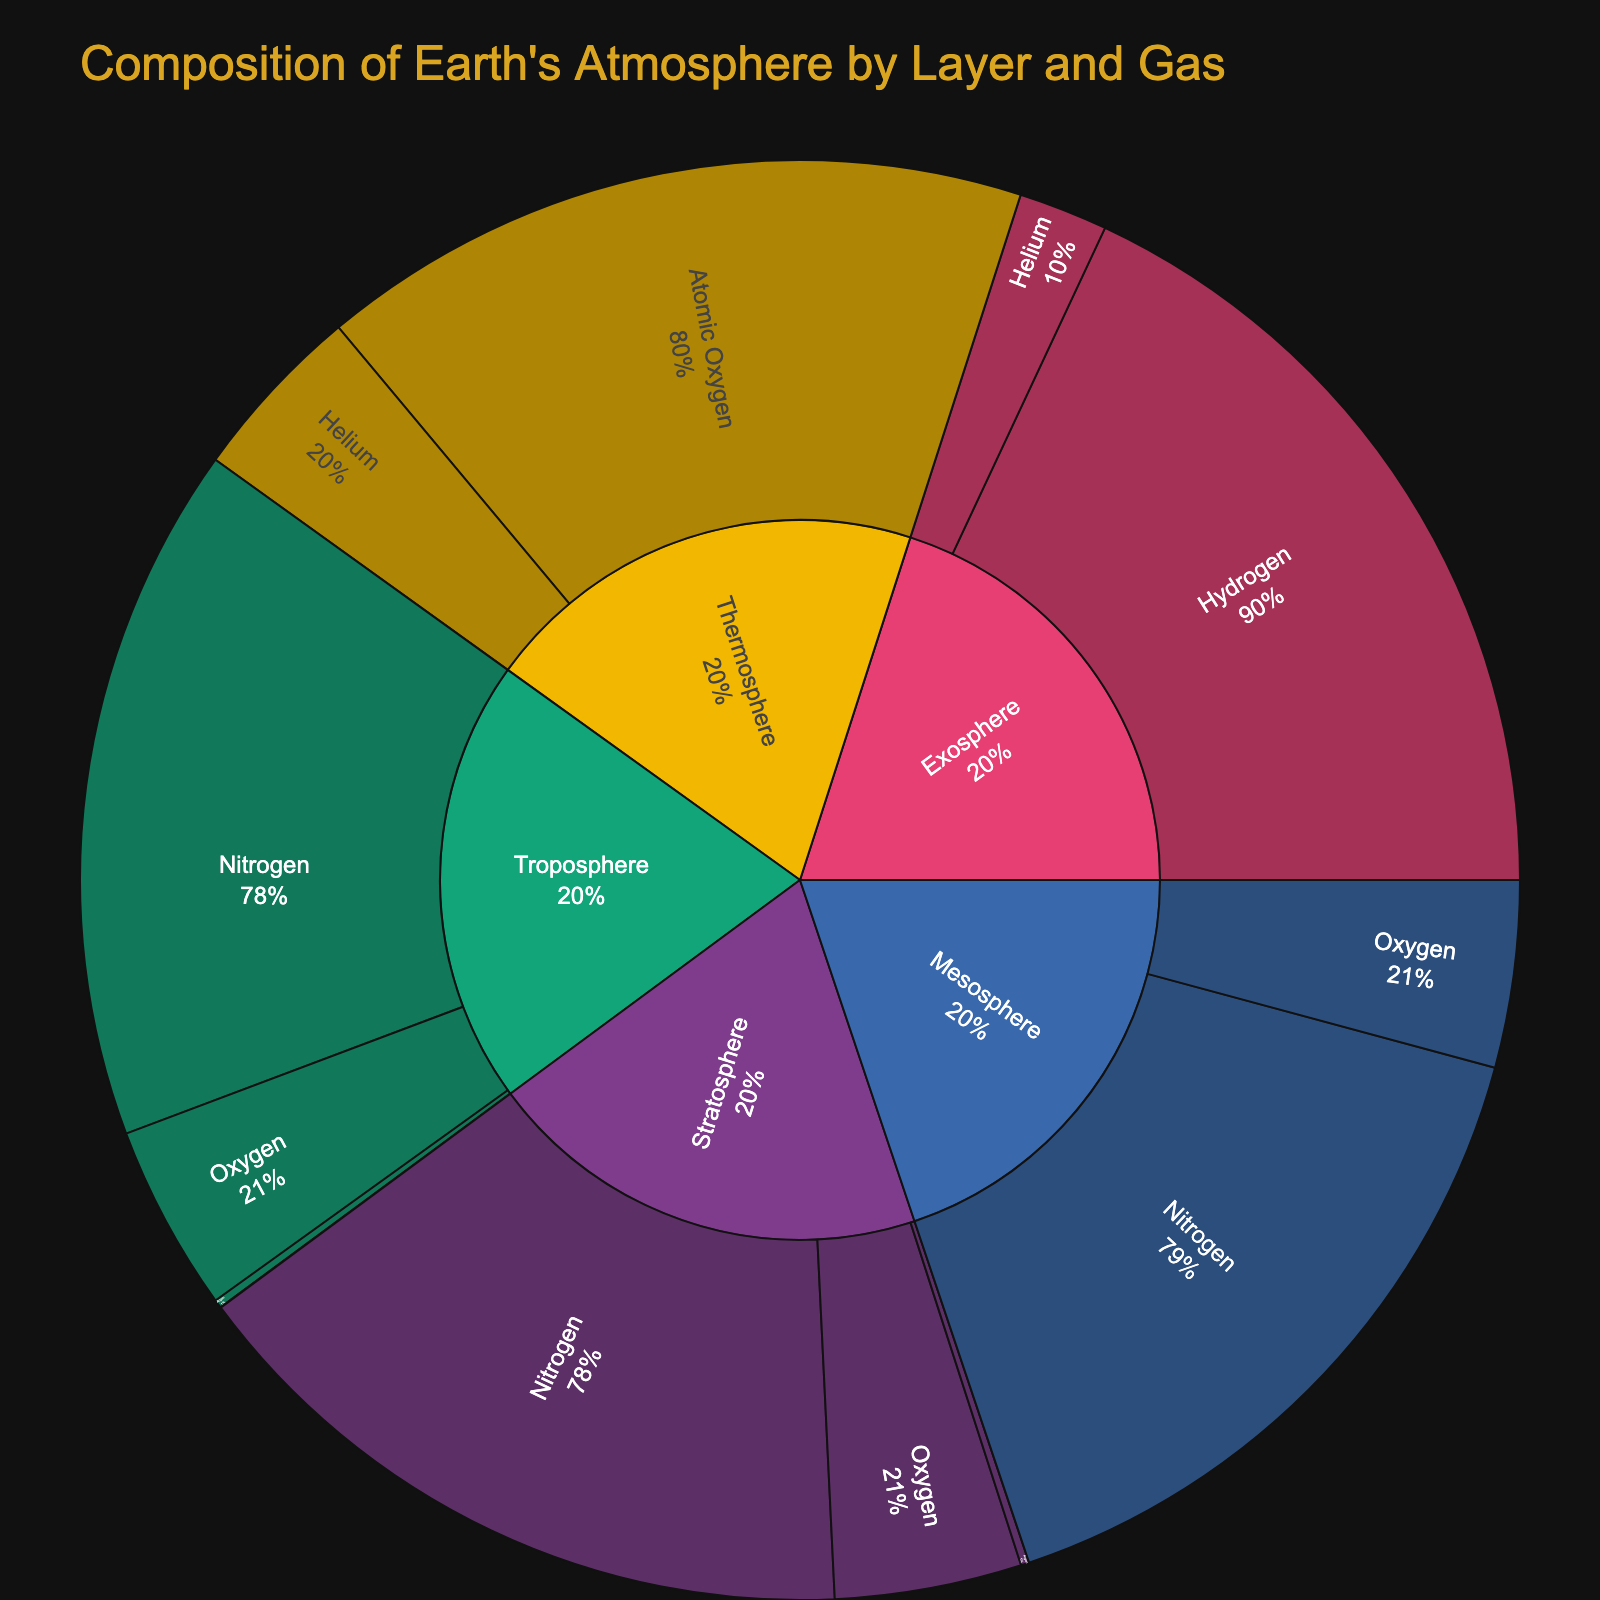Which gas has the highest concentration in the Troposphere? To determine this, look at the section of the sunburst plot corresponding to the Troposphere. Within this section, check the sizes of the individual gas segments. The largest segment represents the gas with the highest concentration.
Answer: Nitrogen What is the concentration of Helium in the Mesosphere? Locate the Mesosphere section in the sunburst plot and then look for the Helium segment within it. The hover info or the label will indicate the concentration.
Answer: 0.0005% Which atmospheric layer has Oxygen as the second most prevalent gas? Examine the segments in each atmospheric layer. The percentage labels within the layers will help identify the most and the second-most prevalent gases.
Answer: Troposphere, Stratosphere, Mesosphere Compute the total concentration of Hydrogen in the Mesosphere, Thermosphere, and Exosphere. Identify the hydrogen segments in each of these layers and sum up their concentrations:  Mesosphere (0.00005) + Thermosphere (0.01) + Exosphere (90).
Answer: 90.01005% Which layers contain Argon, and what is its concentration in each? Look for the Argon segments in the sunburst plot under different layers. Read off the labels or hover info to find concentrations.
Answer: Troposphere (0.93%), Stratosphere (0.93%) Compare the concentration of Ozone in the Stratosphere and the concentration of Carbon Dioxide in the Troposphere. Which one is higher? Examine the respective segments. Ozone in the Stratosphere is 0.0001%, and Carbon Dioxide in the Troposphere is 0.04%.
Answer: Carbon Dioxide in the Troposphere What is the main constituent gas in the Thermosphere? Look for the largest segment within the Thermosphere section in the plot. This segment represents the main constituent gas.
Answer: Atomic Oxygen Which layer has the most varied types of gases based on the number of segments? Count the number of different gas segments within each layer section in the sunburst plot.
Answer: Mesosphere Is the concentration of Hydrogen higher in the Thermosphere or the Mesosphere? Compare the sizes and labels of the Hydrogen segments in both the Thermosphere and the Mesosphere.
Answer: Thermosphere 